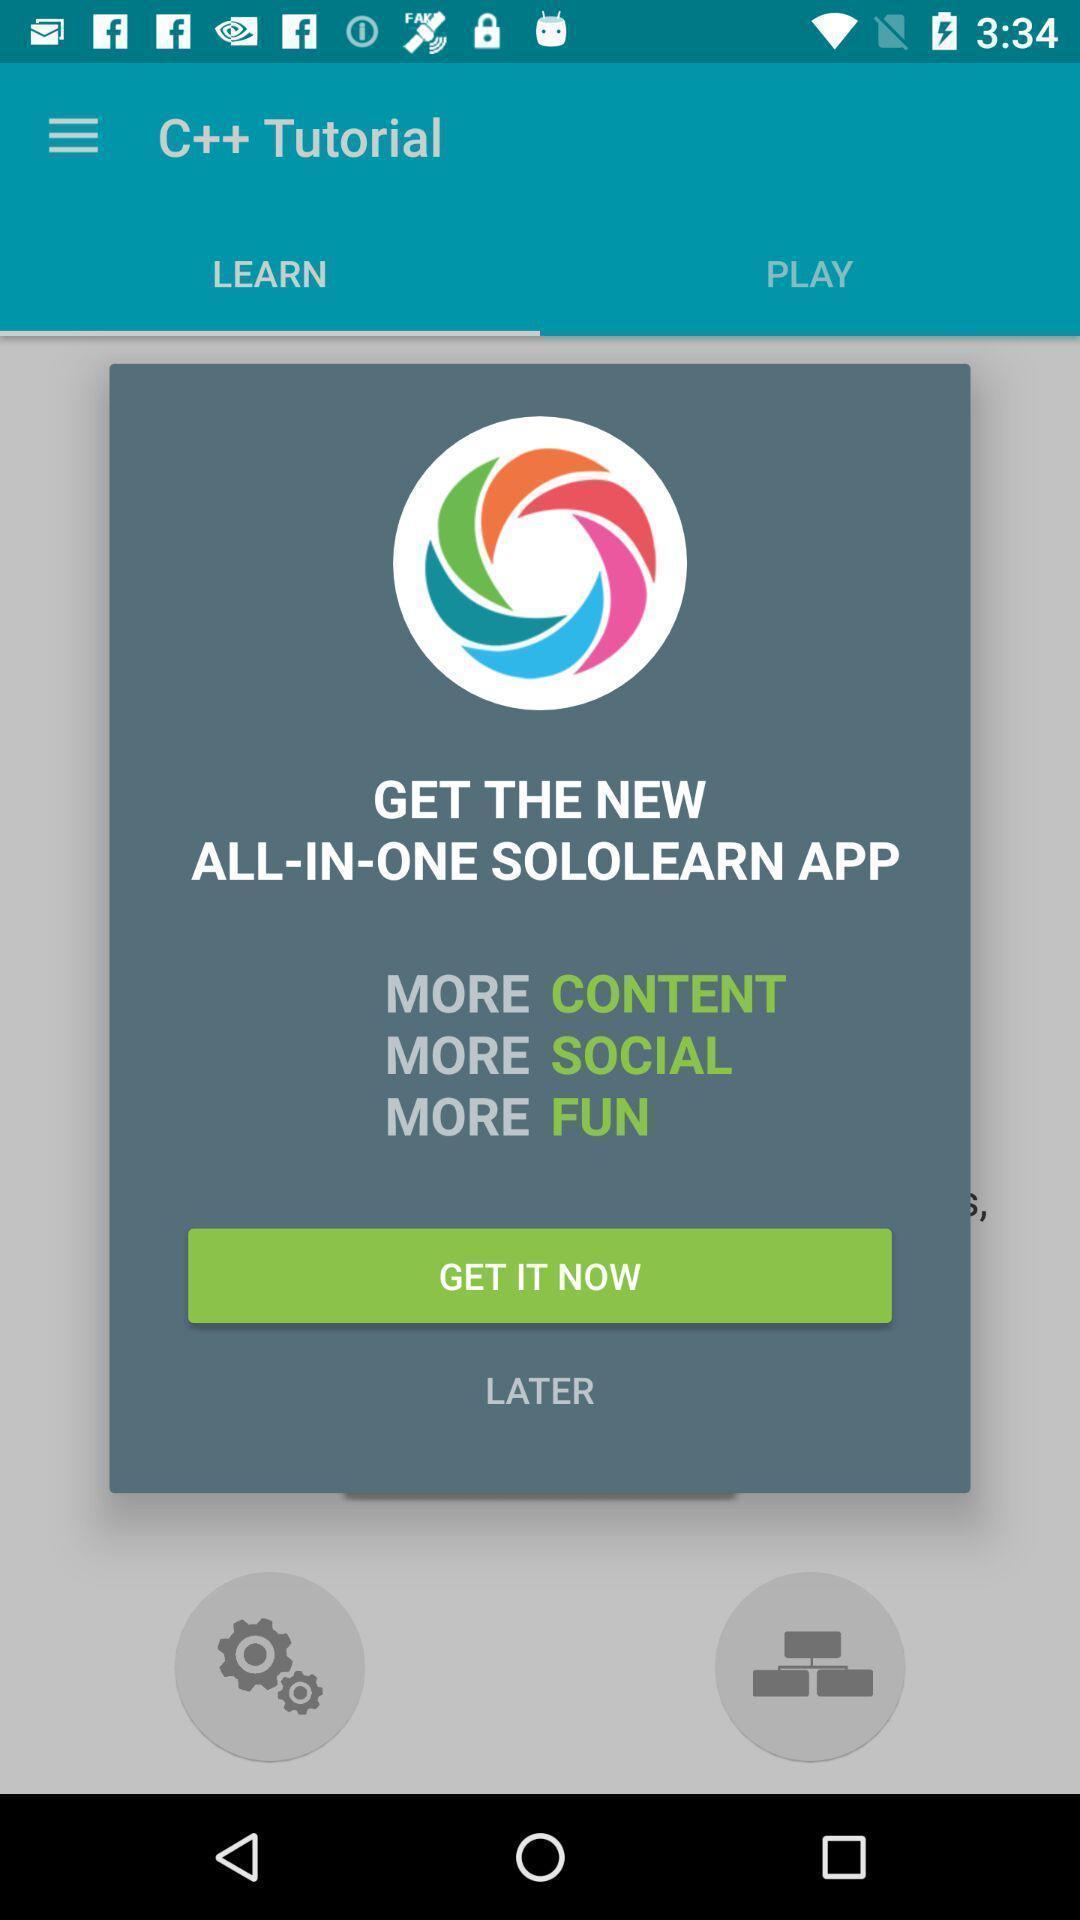Explain what's happening in this screen capture. Pop-up showing notification of a study app. 